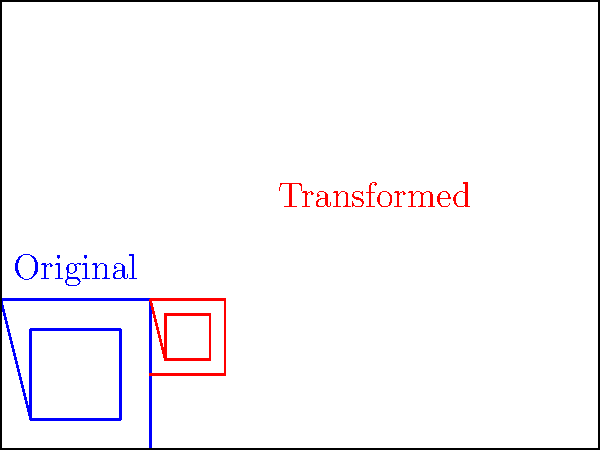An ancient tribal symbol, represented by a square with a smaller square inside, needs to be scaled and translated to fit within a larger rectangular space. The original symbol has a side length of 1 unit, and the inner square has a side length of 0.6 units. The rectangular space measures 4 units in width and 3 units in height. If the symbol is scaled by a factor of 0.5 and then translated 2 units to the right and 1 unit up, what are the coordinates of the top-right corner of the transformed outer square? Let's approach this step-by-step:

1) The original symbol has a side length of 1 unit, with its top-right corner at (1,1).

2) Scaling:
   - Scale factor = 0.5
   - After scaling, the top-right corner will be at $(1 * 0.5, 1 * 0.5) = (0.5, 0.5)$

3) Translation:
   - Translate 2 units right: Add 2 to x-coordinate
   - Translate 1 unit up: Add 1 to y-coordinate

4) Final coordinates:
   - x-coordinate: $0.5 + 2 = 2.5$
   - y-coordinate: $0.5 + 1 = 1.5$

Therefore, the top-right corner of the transformed outer square will be at (2.5, 1.5).
Answer: (2.5, 1.5) 